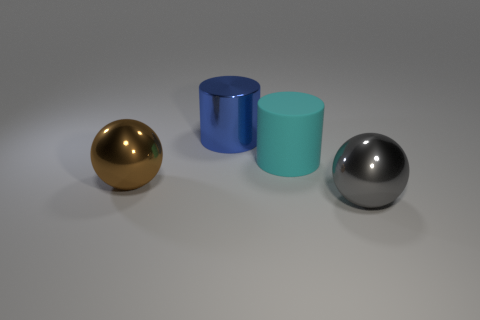Add 1 purple matte objects. How many objects exist? 5 Subtract all blue cylinders. How many cylinders are left? 1 Subtract all red cylinders. Subtract all blue cubes. How many cylinders are left? 2 Subtract all yellow cylinders. How many brown balls are left? 1 Subtract all large metal objects. Subtract all brown things. How many objects are left? 0 Add 4 big cyan things. How many big cyan things are left? 5 Add 2 big green rubber things. How many big green rubber things exist? 2 Subtract 0 gray cylinders. How many objects are left? 4 Subtract 2 cylinders. How many cylinders are left? 0 